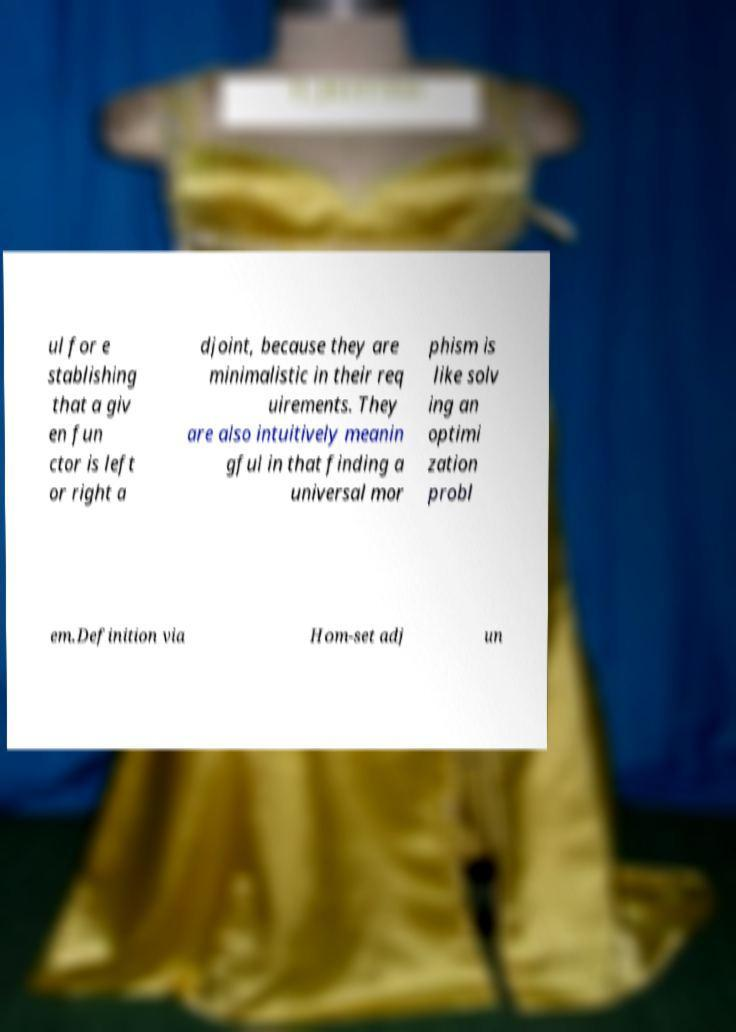What messages or text are displayed in this image? I need them in a readable, typed format. ul for e stablishing that a giv en fun ctor is left or right a djoint, because they are minimalistic in their req uirements. They are also intuitively meanin gful in that finding a universal mor phism is like solv ing an optimi zation probl em.Definition via Hom-set adj un 